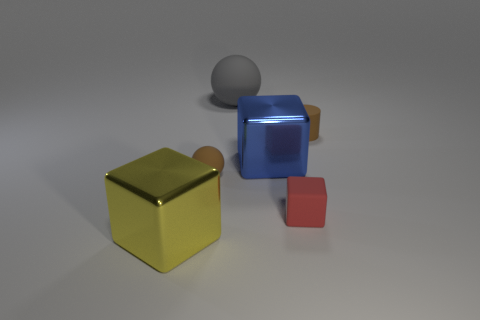There is a tiny brown matte thing left of the large blue metallic object; what number of blue shiny things are to the left of it?
Make the answer very short. 0. The other large ball that is the same material as the brown ball is what color?
Provide a succinct answer. Gray. Is there a sphere that has the same size as the yellow metallic object?
Provide a short and direct response. Yes. The yellow thing that is the same size as the blue metallic block is what shape?
Give a very brief answer. Cube. Is there another thing of the same shape as the red thing?
Offer a terse response. Yes. Do the large blue block and the big cube in front of the large blue thing have the same material?
Your answer should be very brief. Yes. Is there a small shiny object of the same color as the tiny rubber cylinder?
Your answer should be very brief. No. What number of other objects are there of the same material as the large blue object?
Keep it short and to the point. 1. There is a small cylinder; does it have the same color as the metal object that is to the left of the large blue object?
Your answer should be compact. No. Are there more matte things in front of the gray matte ball than red rubber objects?
Offer a very short reply. Yes. 